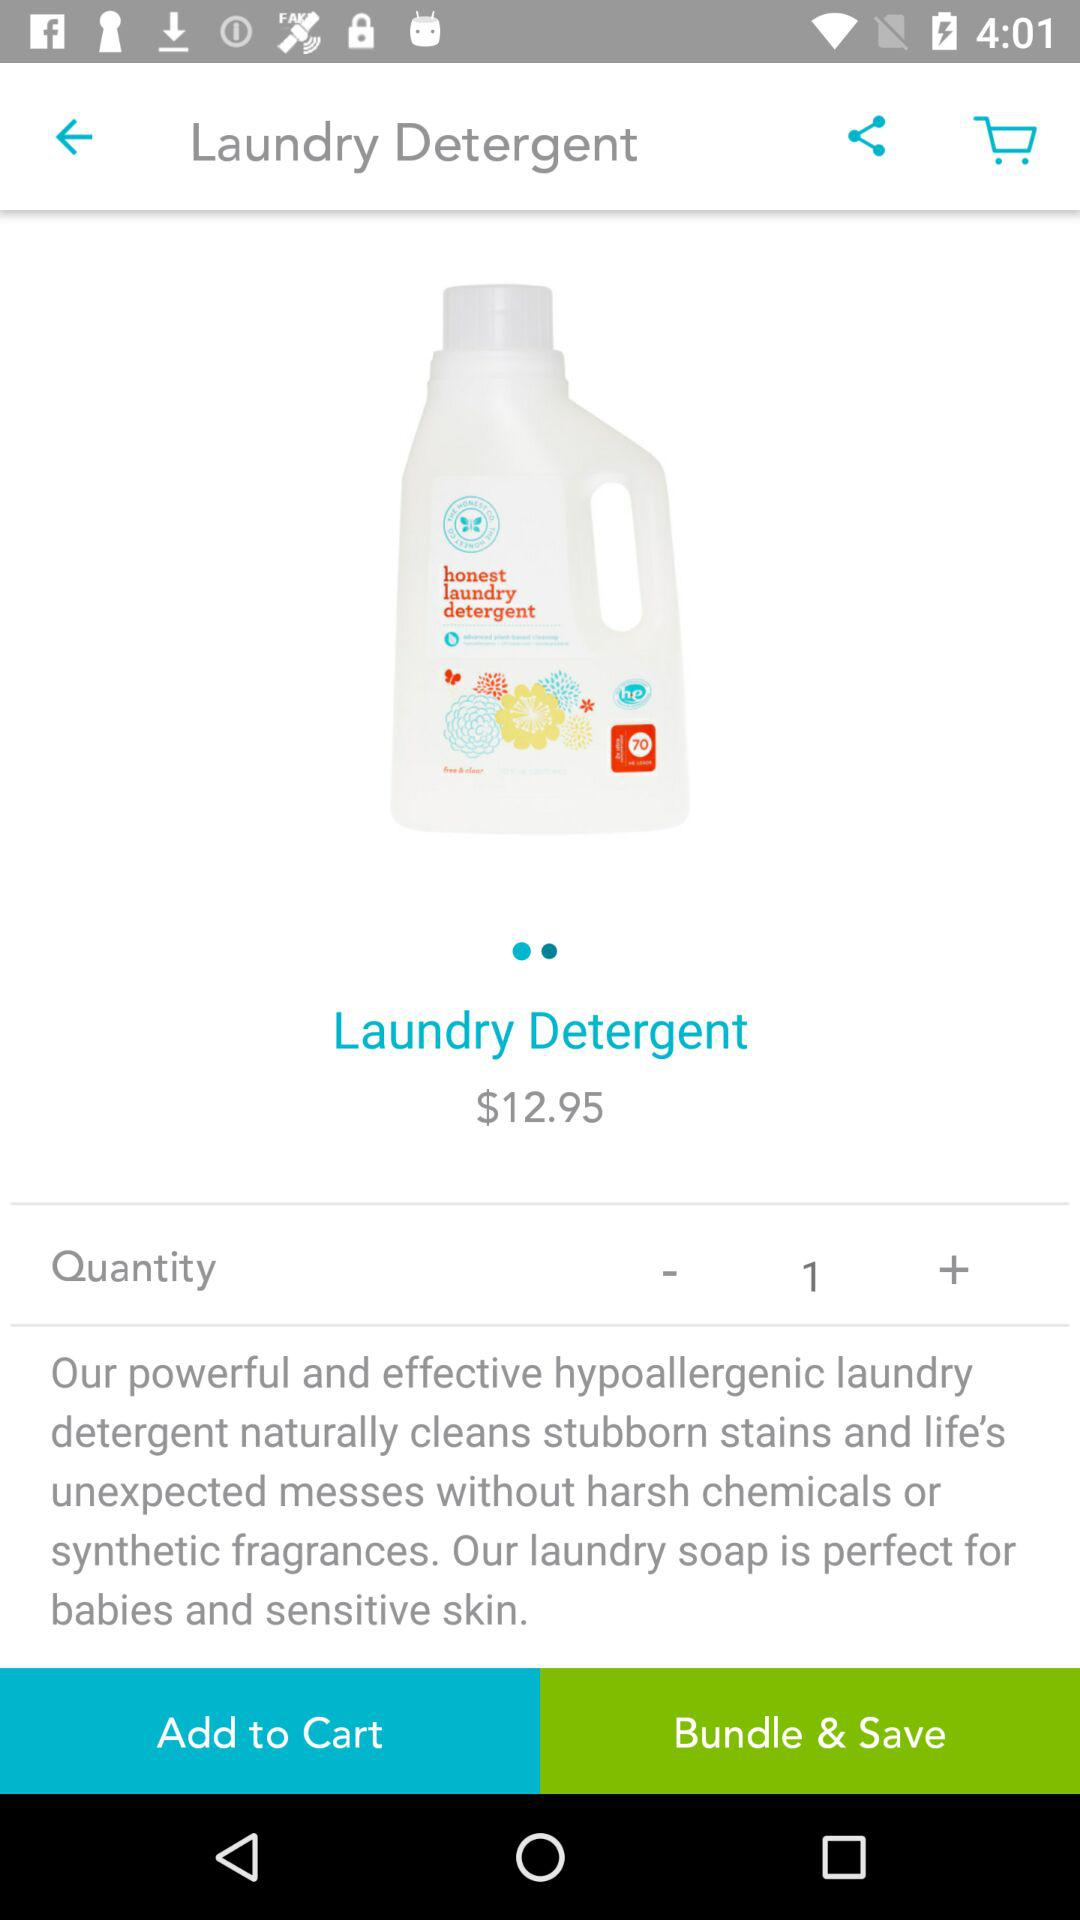What is the quantity? The quantity is 1. 